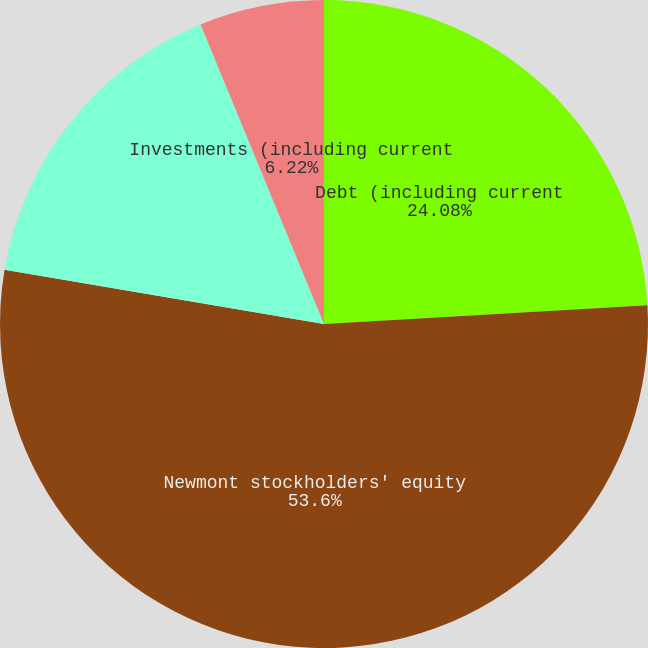Convert chart to OTSL. <chart><loc_0><loc_0><loc_500><loc_500><pie_chart><fcel>Debt (including current<fcel>Newmont stockholders' equity<fcel>Cash and cash equivalents<fcel>Investments (including current<nl><fcel>24.08%<fcel>53.6%<fcel>16.1%<fcel>6.22%<nl></chart> 